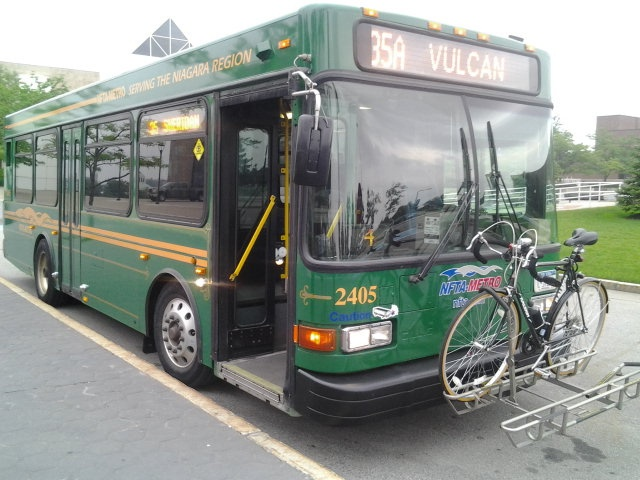Describe the objects in this image and their specific colors. I can see bus in white, darkgray, gray, black, and lightgray tones and bicycle in white, gray, darkgray, lightgray, and black tones in this image. 